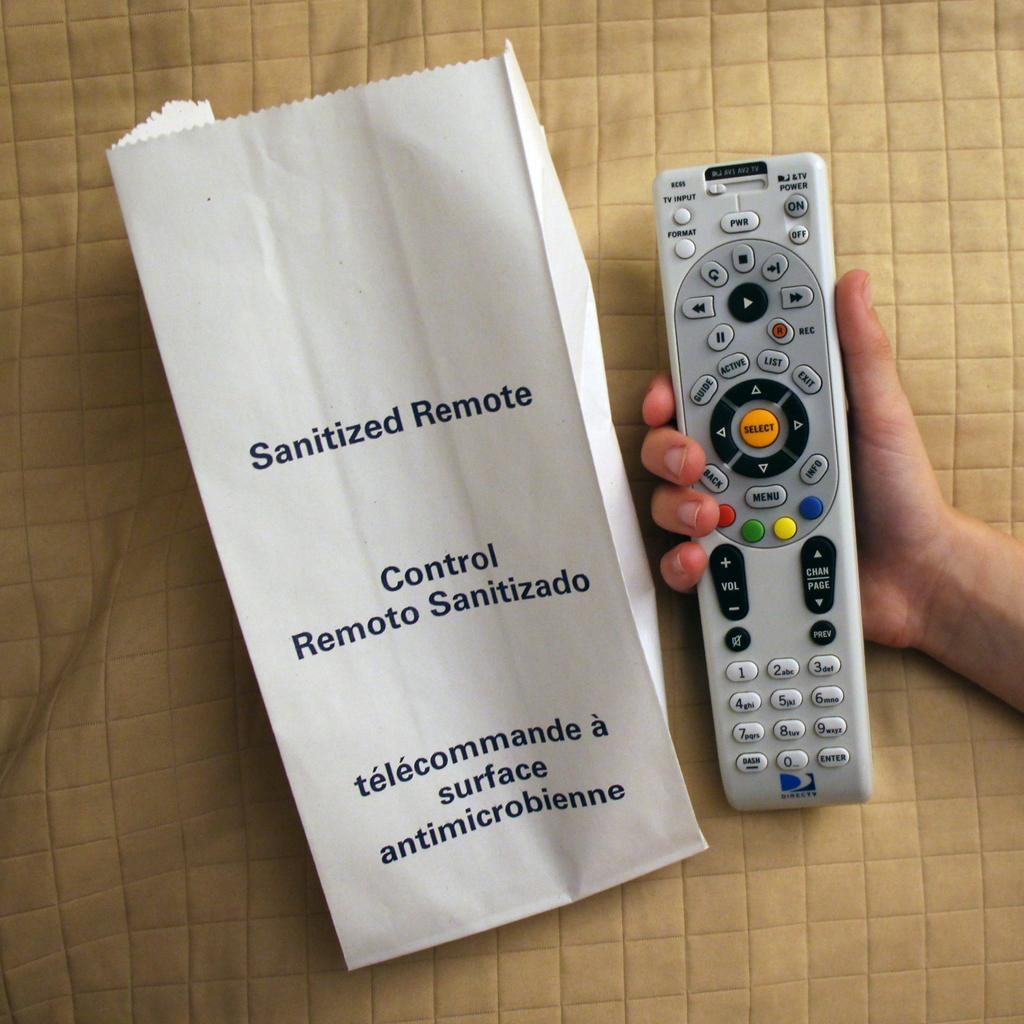<image>
Describe the image concisely. A picture of a hand holding a remote control next to a bag reading 'Sanitized Remote'. 